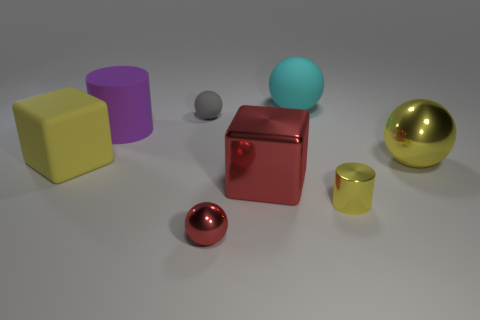Add 2 small green cylinders. How many objects exist? 10 Subtract all big yellow metal spheres. How many spheres are left? 3 Subtract all blue cylinders. How many cyan balls are left? 1 Subtract all yellow metallic balls. Subtract all gray rubber objects. How many objects are left? 6 Add 8 tiny yellow cylinders. How many tiny yellow cylinders are left? 9 Add 5 small metallic objects. How many small metallic objects exist? 7 Subtract all cyan spheres. How many spheres are left? 3 Subtract 1 red spheres. How many objects are left? 7 Subtract all cylinders. How many objects are left? 6 Subtract 1 cylinders. How many cylinders are left? 1 